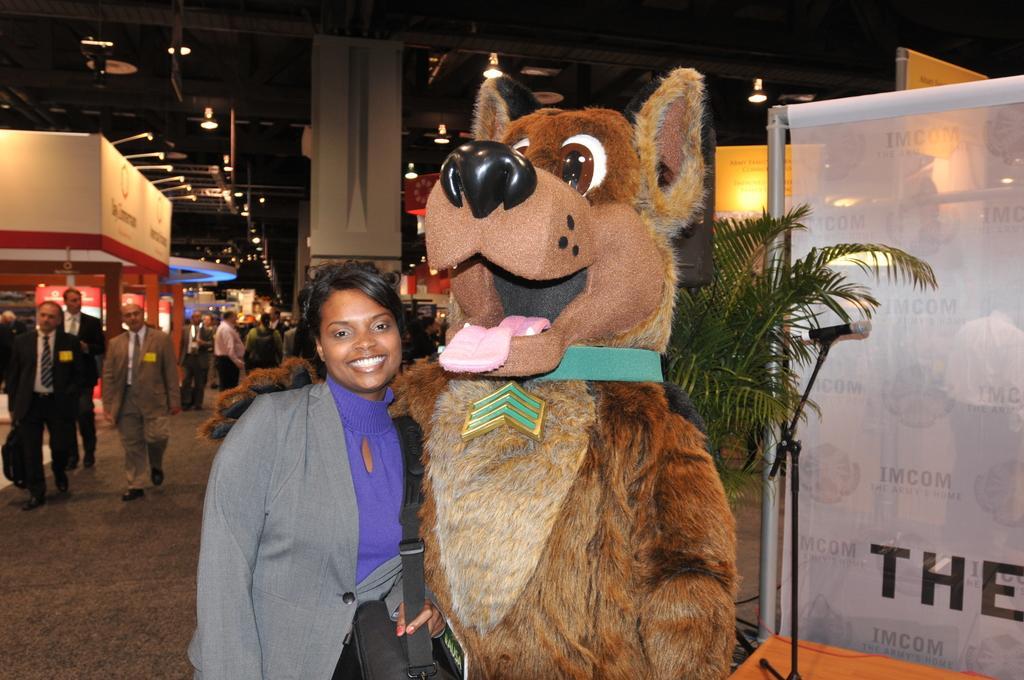In one or two sentences, can you explain what this image depicts? In this picture, we can see a few people, and we can see a person standing beside the toy, and we can see a plant, posters, glass doors, and we can see the roof with lights, and we can see microphone, pillar, store, and we can see the ground. 